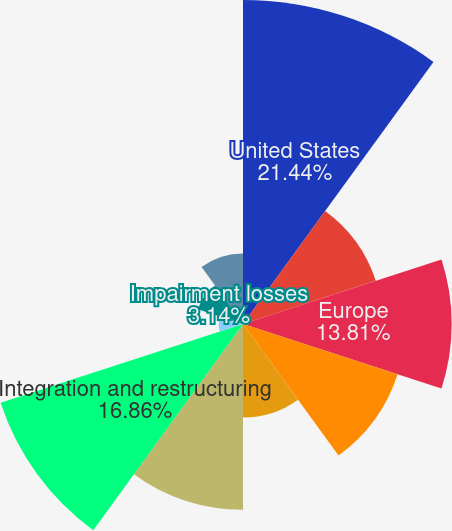Convert chart. <chart><loc_0><loc_0><loc_500><loc_500><pie_chart><fcel>United States<fcel>Canada<fcel>Europe<fcel>Rest of World<fcel>General corporate expenses<fcel>Depreciation and amortization<fcel>Integration and restructuring<fcel>Unrealized gains/(losses) on<fcel>Impairment losses<fcel>Equity award compensation<nl><fcel>21.44%<fcel>9.24%<fcel>13.81%<fcel>10.76%<fcel>6.19%<fcel>12.29%<fcel>16.86%<fcel>1.61%<fcel>3.14%<fcel>4.66%<nl></chart> 